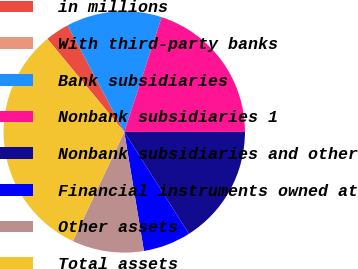Convert chart. <chart><loc_0><loc_0><loc_500><loc_500><pie_chart><fcel>in millions<fcel>With third-party banks<fcel>Bank subsidiaries<fcel>Nonbank subsidiaries 1<fcel>Nonbank subsidiaries and other<fcel>Financial instruments owned at<fcel>Other assets<fcel>Total assets<nl><fcel>3.2%<fcel>0.0%<fcel>12.8%<fcel>19.98%<fcel>16.0%<fcel>6.4%<fcel>9.6%<fcel>32.0%<nl></chart> 